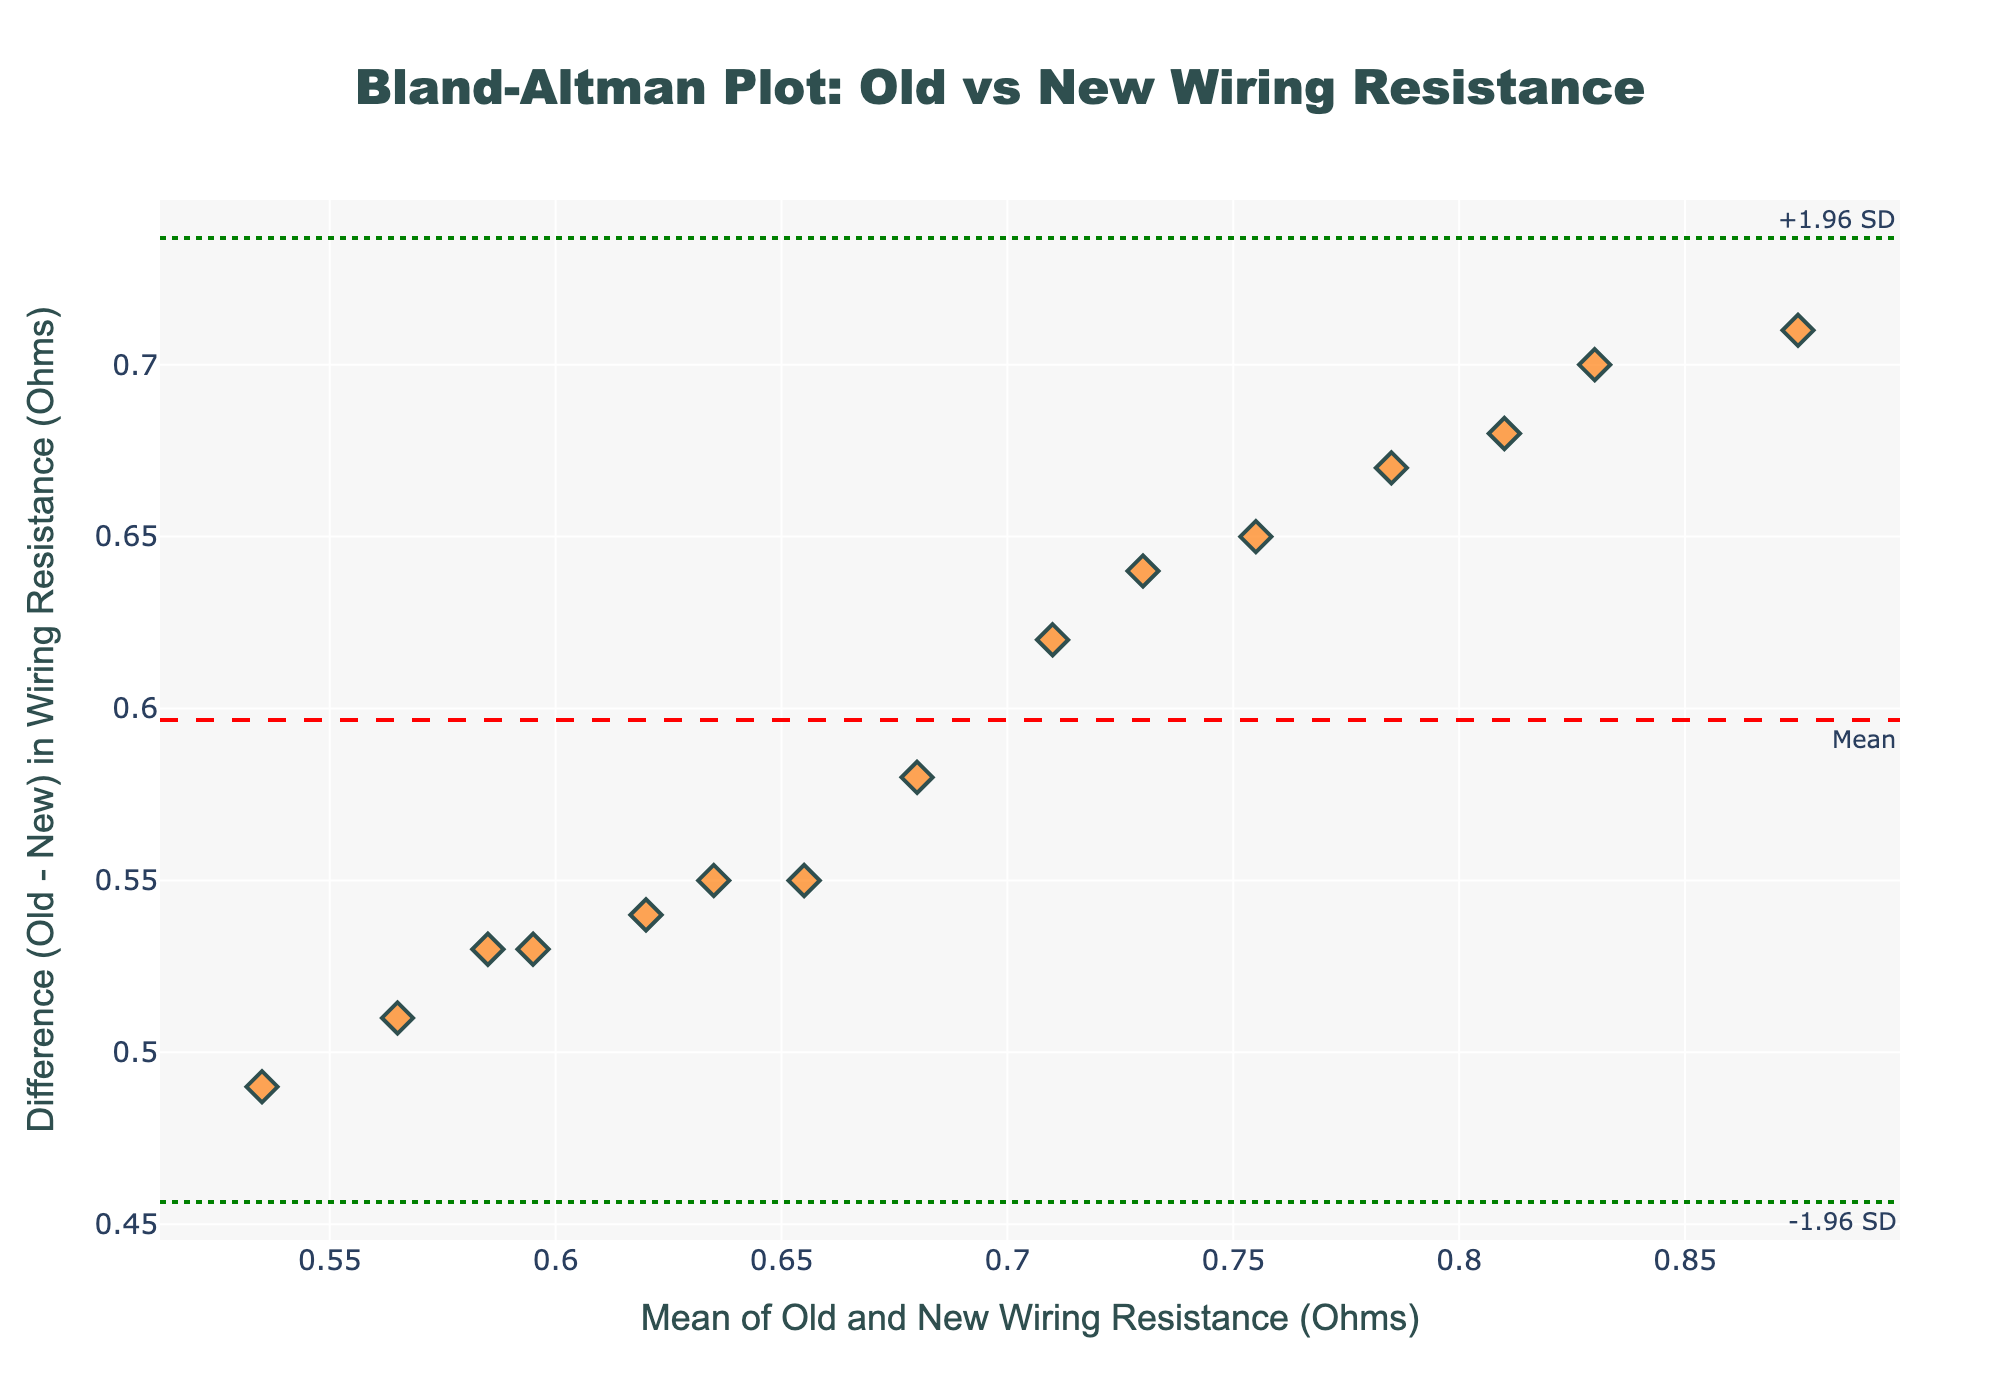What is the title of the plot? The plot title is generally located at the top of the figure, indicating what the plot is about. By examining the top of the figure, we can see the title text.
Answer: Bland-Altman Plot: Old vs New Wiring Resistance How many data points are shown in the plot? To find the number of data points, simply count the number of markers (e.g., diamonds) shown in the scatter plot. By inspecting the figure, we can tally the markers.
Answer: 15 What is the mean difference between old and new wiring resistance? On a Bland-Altman plot, the mean difference is displayed as a dashed horizontal line. The annotation along this line in the plot specifies its value.
Answer: Mean (in red dashed line) What do the two green dotted lines represent in the plot? In a Bland-Altman plot, the two green dotted lines typically represent the limits of agreement, which are calculated as the mean difference +/- 1.96 times the standard deviation of the differences.
Answer: Limits of Agreement (+1.96 SD and -1.96 SD) What is the maximum difference between old and new wiring resistance observed in the plot? To find the maximum difference, look for the data point that has the highest vertical distance from the mean difference line on the y-axis. This difference corresponds to the furthest scatter point from the mean line.
Answer: Look at highest point above red dashed line What does a negative difference in the plot indicate? A negative difference means that the resistance of the old wiring is less than that of the new wiring. This can be inferred from the y-axis of the plot where negative values represent a decrease in resistance.
Answer: Old wiring resistance is less than new wiring How tightly are the data points clustered around the mean difference line? This can be assessed by visually inspecting the spread of the points around the dashed line. A tighter clustering would indicate less variation among the differences.
Answer: Moderately clustered Are any of the data points lying outside the limits of agreement? A Bland-Altman plot usually expects most points to fall within the limits of agreement. By carefully checking the scatter plot, we can see if any points lie beyond the green dotted lines.
Answer: No Which limit of agreement is higher, the upper or the lower one? Limits of agreement are derived from the mean difference and standard deviations. Thus, the upper limit is higher than the lower limit and can be seen in the plot's annotations.
Answer: Upper limit 